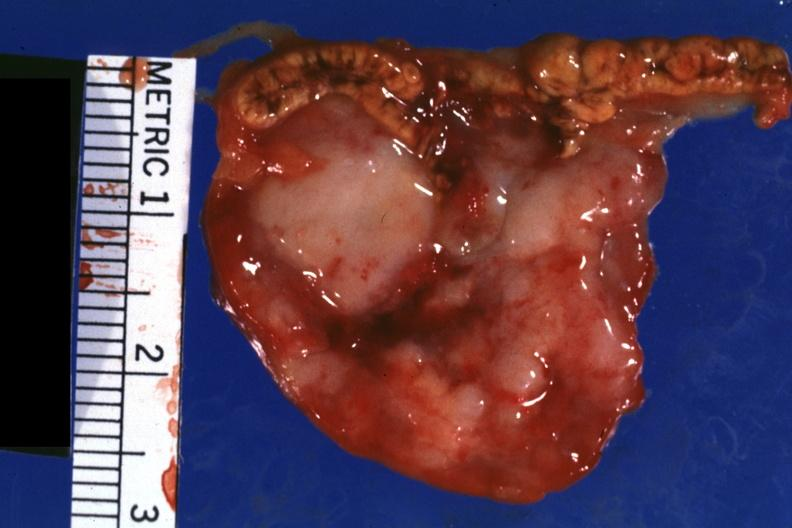where does this belong to?
Answer the question using a single word or phrase. Endocrine system 